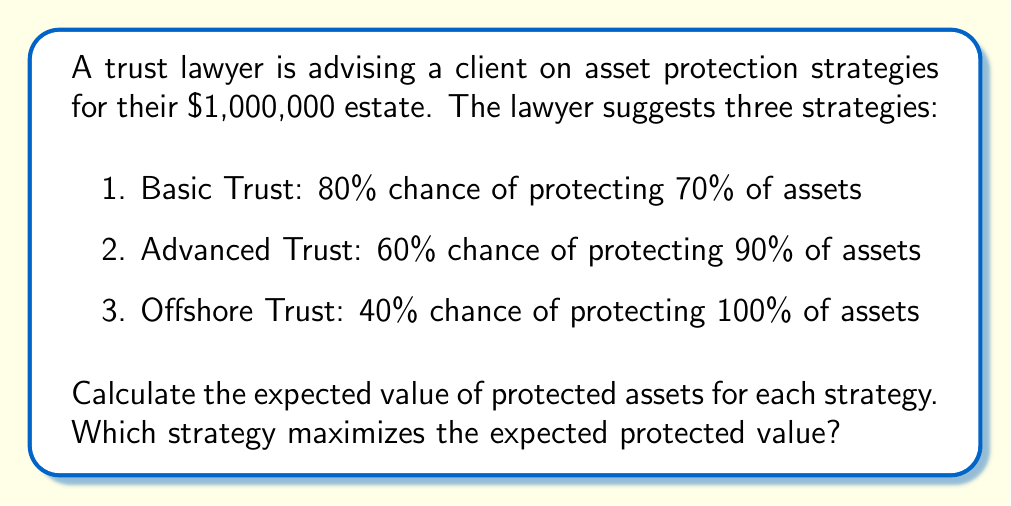Solve this math problem. To solve this problem, we need to calculate the expected value of protected assets for each strategy using the formula:

$$ E(X) = p \cdot X $$

Where $E(X)$ is the expected value, $p$ is the probability of success, and $X$ is the value of protected assets.

1. Basic Trust:
   $$ E(X_1) = 0.80 \cdot (0.70 \cdot \$1,000,000) = 0.80 \cdot \$700,000 = \$560,000 $$

2. Advanced Trust:
   $$ E(X_2) = 0.60 \cdot (0.90 \cdot \$1,000,000) = 0.60 \cdot \$900,000 = \$540,000 $$

3. Offshore Trust:
   $$ E(X_3) = 0.40 \cdot (1.00 \cdot \$1,000,000) = 0.40 \cdot \$1,000,000 = \$400,000 $$

Comparing the expected values:
$$ E(X_1) = \$560,000 > E(X_2) = \$540,000 > E(X_3) = \$400,000 $$

Therefore, the Basic Trust strategy maximizes the expected protected value.
Answer: The expected values of protected assets for each strategy are:
1. Basic Trust: $560,000
2. Advanced Trust: $540,000
3. Offshore Trust: $400,000

The Basic Trust strategy maximizes the expected protected value at $560,000. 